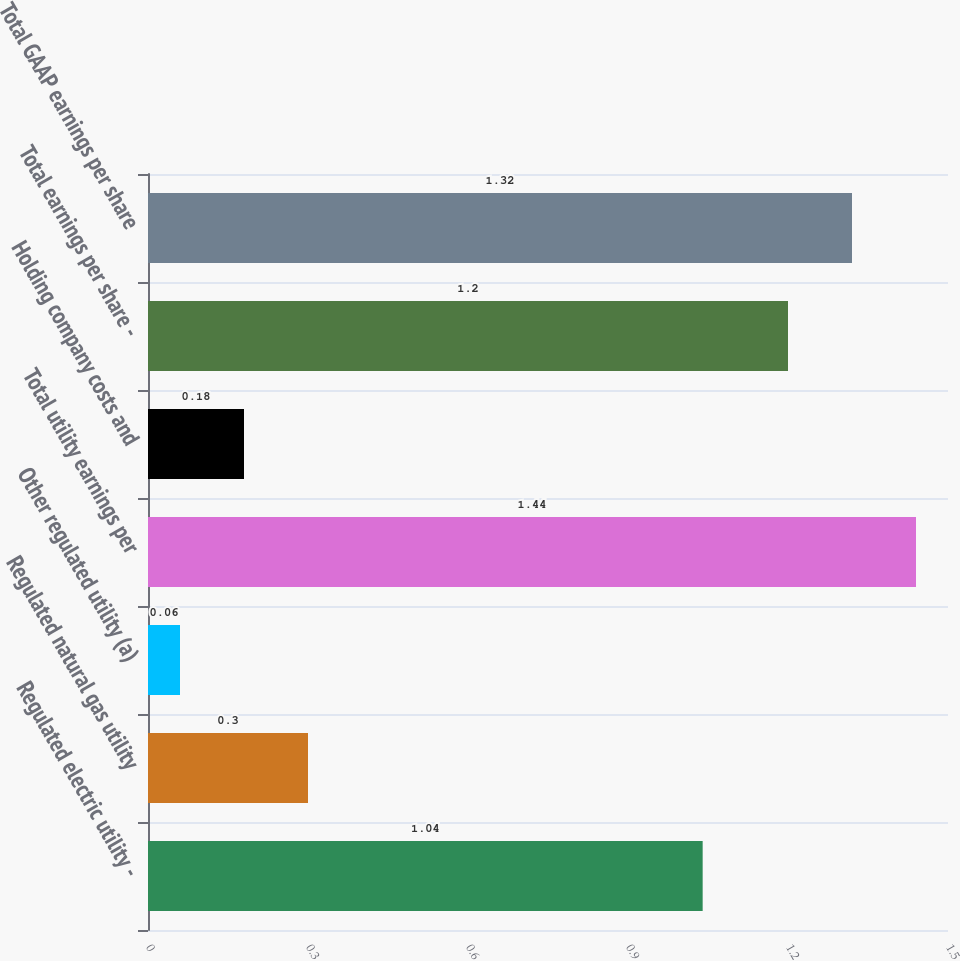Convert chart to OTSL. <chart><loc_0><loc_0><loc_500><loc_500><bar_chart><fcel>Regulated electric utility -<fcel>Regulated natural gas utility<fcel>Other regulated utility (a)<fcel>Total utility earnings per<fcel>Holding company costs and<fcel>Total earnings per share -<fcel>Total GAAP earnings per share<nl><fcel>1.04<fcel>0.3<fcel>0.06<fcel>1.44<fcel>0.18<fcel>1.2<fcel>1.32<nl></chart> 